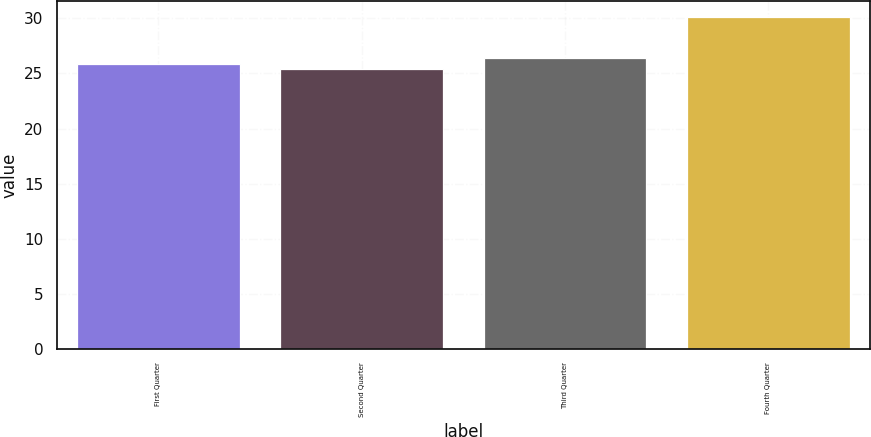Convert chart. <chart><loc_0><loc_0><loc_500><loc_500><bar_chart><fcel>First Quarter<fcel>Second Quarter<fcel>Third Quarter<fcel>Fourth Quarter<nl><fcel>25.89<fcel>25.37<fcel>26.4<fcel>30.1<nl></chart> 